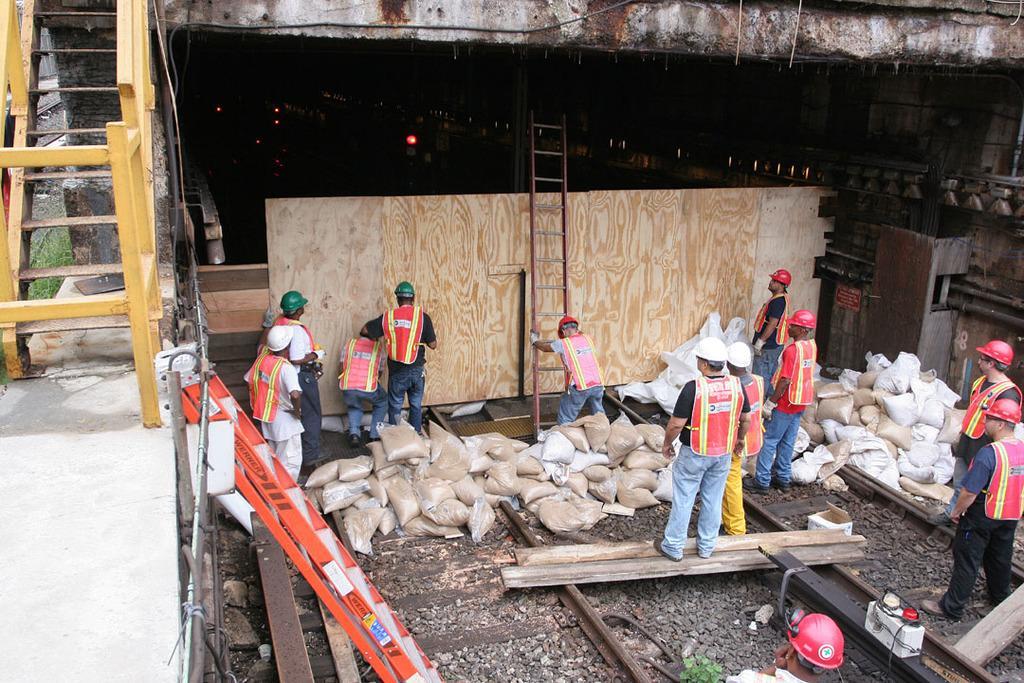In one or two sentences, can you explain what this image depicts? In the picture I can see a few men standing on the railway tracks. They are wearing the safety jacket and I can see the hard hat on their head. I can see a man holding the ladder. There is a metal staircase on the top left side of the picture. I can see the wooden block. 